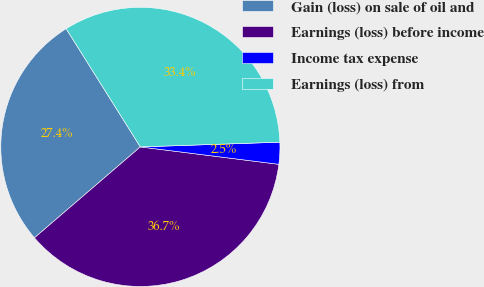<chart> <loc_0><loc_0><loc_500><loc_500><pie_chart><fcel>Gain (loss) on sale of oil and<fcel>Earnings (loss) before income<fcel>Income tax expense<fcel>Earnings (loss) from<nl><fcel>27.37%<fcel>36.72%<fcel>2.53%<fcel>33.38%<nl></chart> 